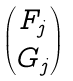Convert formula to latex. <formula><loc_0><loc_0><loc_500><loc_500>\begin{pmatrix} F _ { j } \\ G _ { j } \end{pmatrix}</formula> 